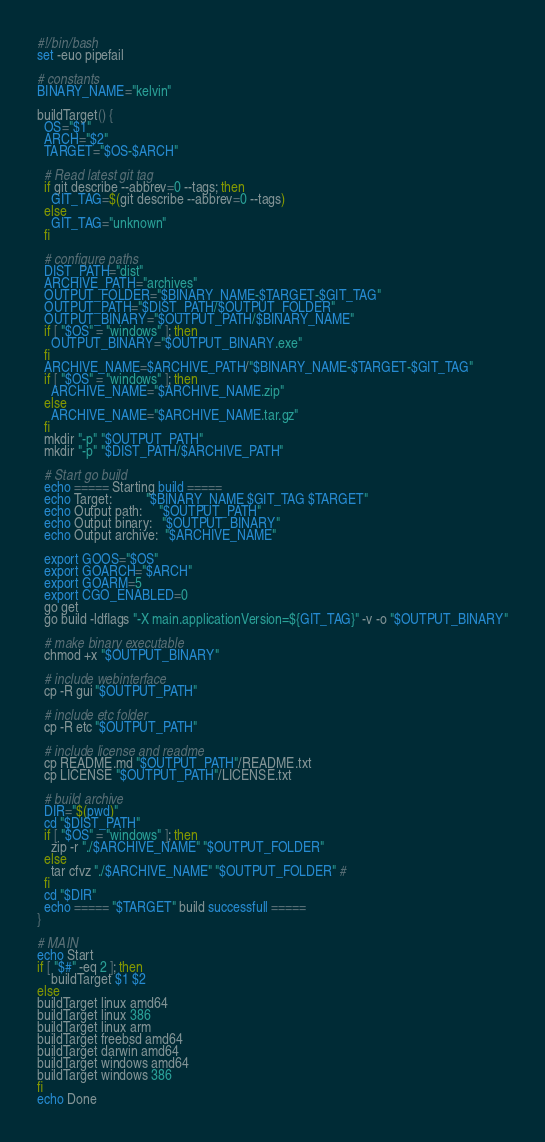<code> <loc_0><loc_0><loc_500><loc_500><_Bash_>#!/bin/bash
set -euo pipefail

# constants
BINARY_NAME="kelvin"

buildTarget() {
  OS="$1"
  ARCH="$2"
  TARGET="$OS-$ARCH"

  # Read latest git tag
  if git describe --abbrev=0 --tags; then
    GIT_TAG=$(git describe --abbrev=0 --tags)
  else
    GIT_TAG="unknown"
  fi

  # configure paths
  DIST_PATH="dist"
  ARCHIVE_PATH="archives"
  OUTPUT_FOLDER="$BINARY_NAME-$TARGET-$GIT_TAG"
  OUTPUT_PATH="$DIST_PATH/$OUTPUT_FOLDER"
  OUTPUT_BINARY="$OUTPUT_PATH/$BINARY_NAME"
  if [ "$OS" = "windows" ]; then
    OUTPUT_BINARY="$OUTPUT_BINARY.exe"
  fi
  ARCHIVE_NAME=$ARCHIVE_PATH/"$BINARY_NAME-$TARGET-$GIT_TAG"
  if [ "$OS" = "windows" ]; then
    ARCHIVE_NAME="$ARCHIVE_NAME.zip"
  else
    ARCHIVE_NAME="$ARCHIVE_NAME.tar.gz"
  fi
  mkdir "-p" "$OUTPUT_PATH"
  mkdir "-p" "$DIST_PATH/$ARCHIVE_PATH"

  # Start go build
  echo ===== Starting build =====
  echo Target:          "$BINARY_NAME $GIT_TAG $TARGET"
  echo Output path:     "$OUTPUT_PATH"
  echo Output binary:   "$OUTPUT_BINARY"
  echo Output archive:  "$ARCHIVE_NAME"

  export GOOS="$OS"
  export GOARCH="$ARCH"
  export GOARM=5
  export CGO_ENABLED=0
  go get
  go build -ldflags "-X main.applicationVersion=${GIT_TAG}" -v -o "$OUTPUT_BINARY"

  # make binary executable
  chmod +x "$OUTPUT_BINARY"

  # include webinterface
  cp -R gui "$OUTPUT_PATH"

  # include etc folder
  cp -R etc "$OUTPUT_PATH"

  # include license and readme
  cp README.md "$OUTPUT_PATH"/README.txt
  cp LICENSE "$OUTPUT_PATH"/LICENSE.txt

  # build archive
  DIR="$(pwd)"
  cd "$DIST_PATH"
  if [ "$OS" = "windows" ]; then
    zip -r "./$ARCHIVE_NAME" "$OUTPUT_FOLDER"
  else
    tar cfvz "./$ARCHIVE_NAME" "$OUTPUT_FOLDER" #
  fi
  cd "$DIR"
  echo ===== "$TARGET" build successfull =====
}

# MAIN
echo Start
if [ "$#" -eq 2 ]; then
    buildTarget $1 $2
else
buildTarget linux amd64
buildTarget linux 386
buildTarget linux arm
buildTarget freebsd amd64
buildTarget darwin amd64
buildTarget windows amd64
buildTarget windows 386
fi
echo Done
</code> 